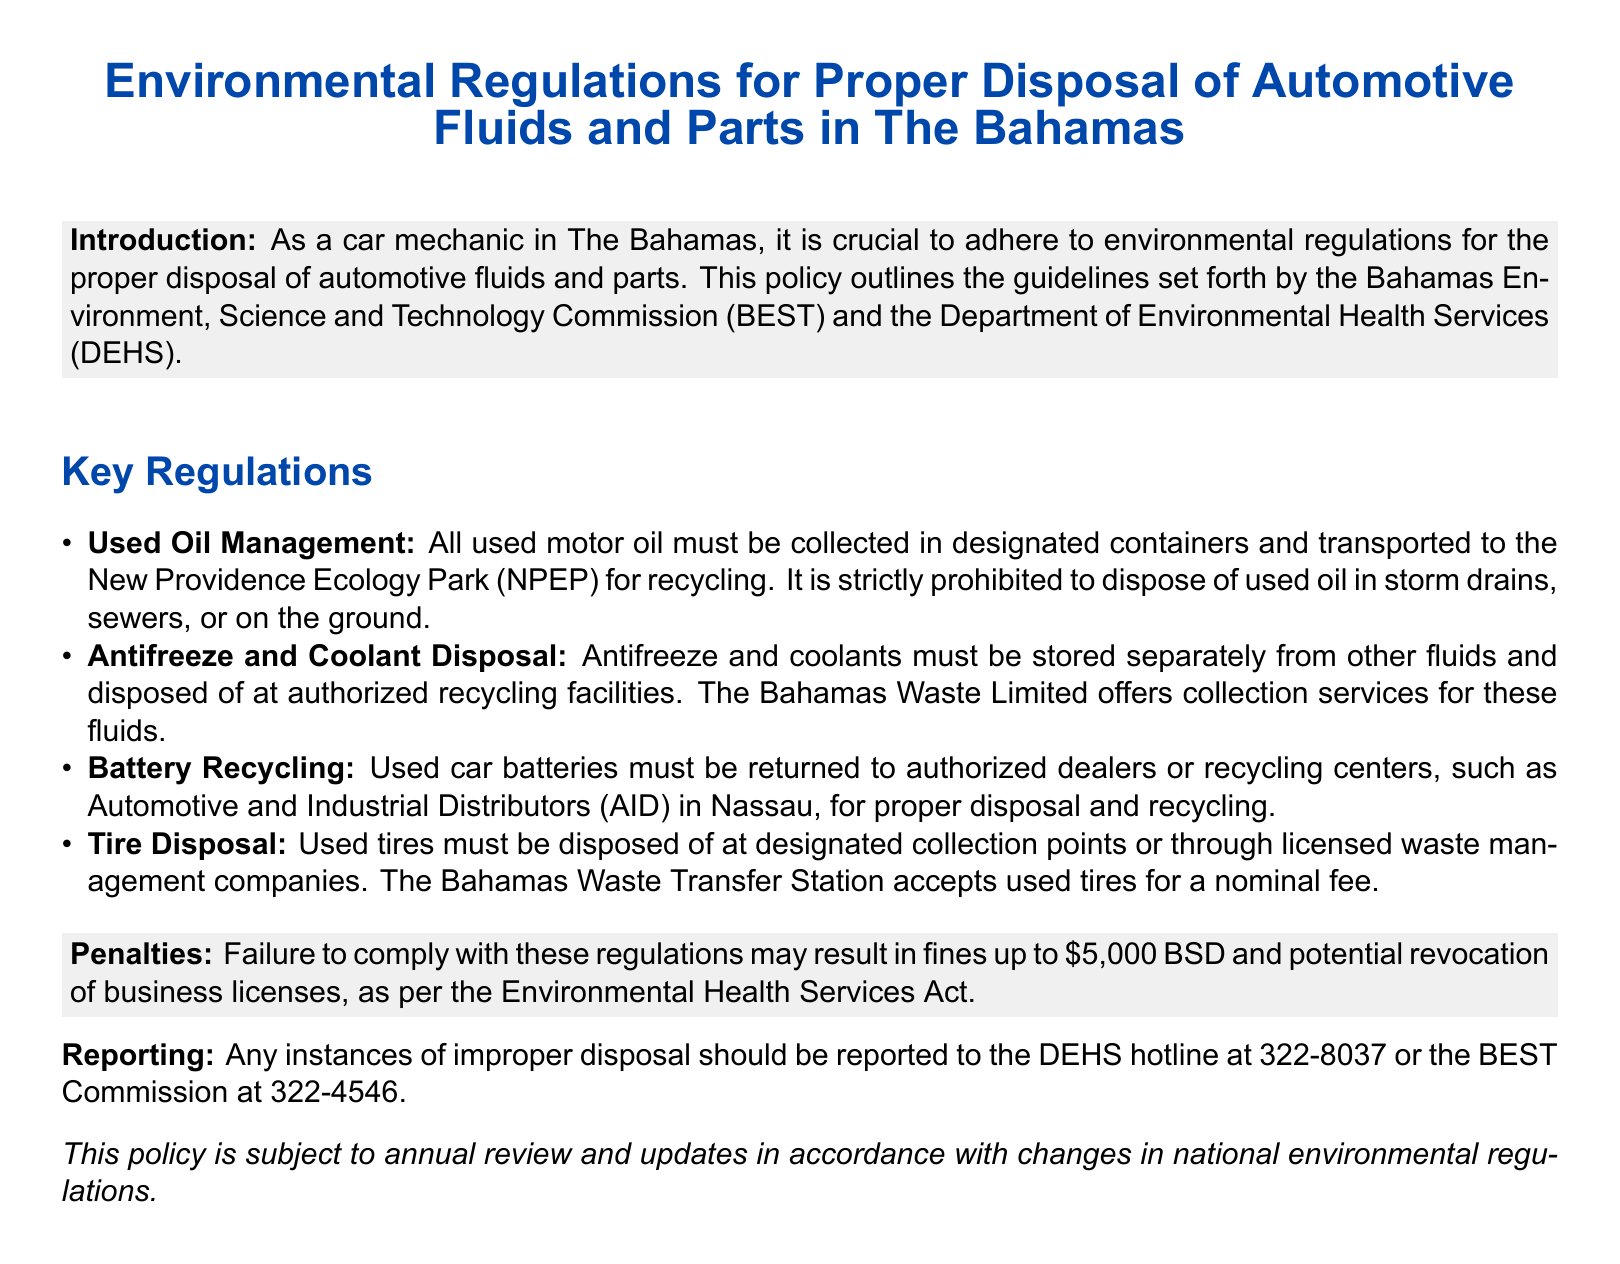What must used motor oil be transported to? The document specifies that used motor oil must be transported to the New Providence Ecology Park for recycling.
Answer: New Providence Ecology Park What is strictly prohibited regarding used oil disposal? The document indicates that it is prohibited to dispose of used oil in storm drains, sewers, or on the ground.
Answer: Storm drains, sewers, or on the ground Who offers collection services for antifreeze and coolants? The document states that the Bahamas Waste Limited offers collection services for antifreeze and coolants.
Answer: Bahamas Waste Limited What is the maximum fine for non-compliance with these regulations? The document mentions that failure to comply with the regulations may result in fines up to $5,000 BSD.
Answer: $5,000 BSD Where should used car batteries be returned for disposal? According to the document, used car batteries must be returned to authorized dealers or recycling centers for proper disposal.
Answer: Authorized dealers or recycling centers What is the fee for disposing tires at the Bahamas Waste Transfer Station? The document indicates that used tires can be disposed of at the Bahamas Waste Transfer Station for a nominal fee, though it does not specify the amount.
Answer: Nominal fee What must be reported to the DEHS hotline? The document states that any instances of improper disposal should be reported to the DEHS hotline.
Answer: Improper disposal Which commission is responsible for environmental regulations in The Bahamas? The document specifies that the guidelines are set forth by the Bahamas Environment, Science and Technology Commission (BEST).
Answer: BEST 